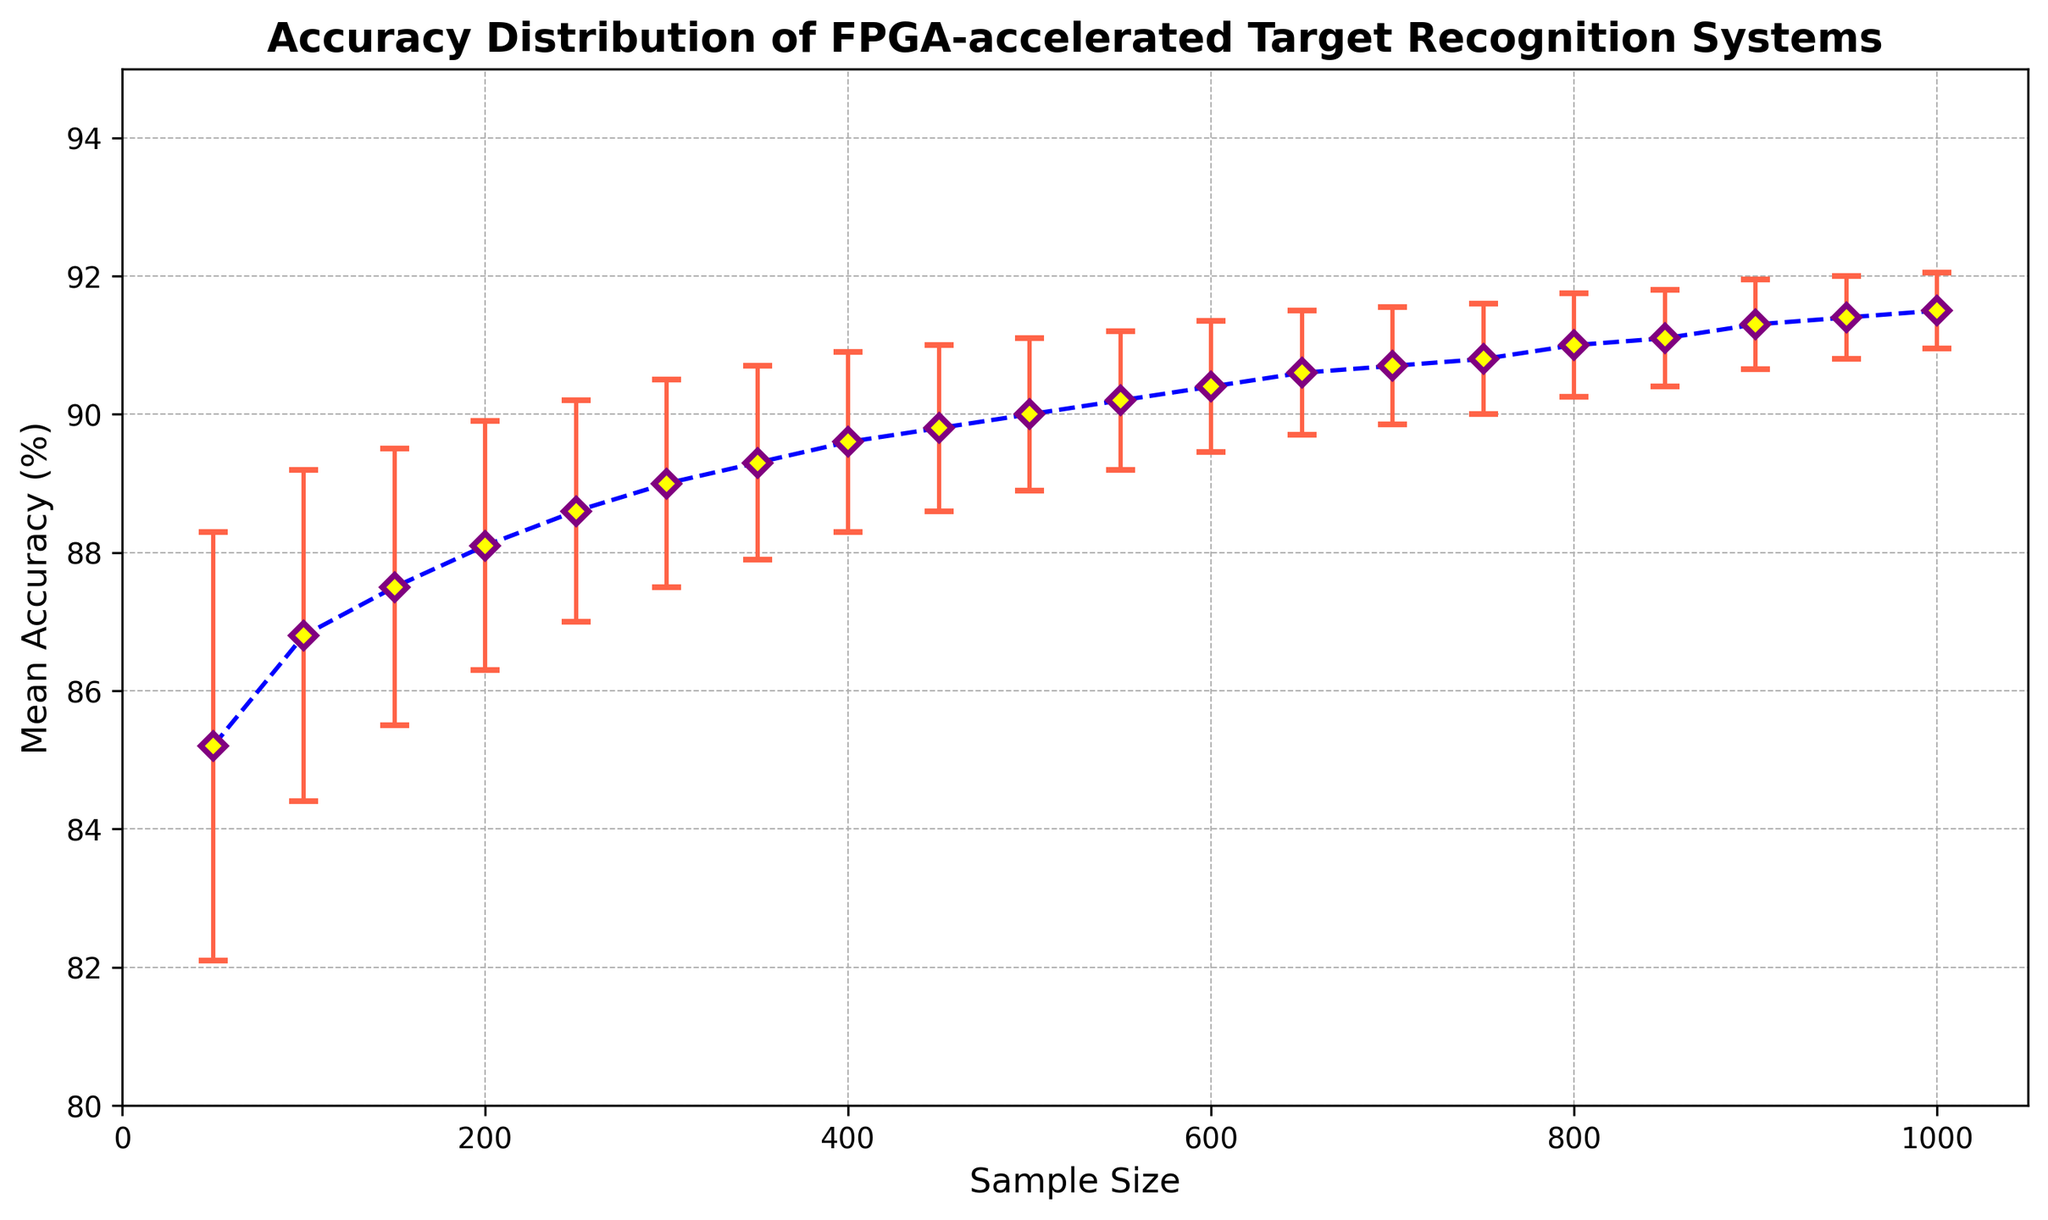How does the mean accuracy change as the sample size increases from 50 to 1000? Initially, at a sample size of 50, the mean accuracy is 85.2%. As the sample size increases, the mean accuracy steadily rises, reaching 91.5% at a sample size of 1000. Thus, there is a clear upward trend in mean accuracy as the sample size grows.
Answer: The mean accuracy increases from 85.2% to 91.5% What is the difference in mean accuracy between a sample size of 50 and a sample size of 1000? The mean accuracy at a sample size of 50 is 85.2%, and at 1000, it is 91.5%. The difference is calculated as 91.5% - 85.2%.
Answer: 6.3% For which sample size does the mean accuracy first reach or exceed 90%? By examining the plot, we see that the mean accuracy reaches 90% at a sample size of 500. This is the first instance where the mean accuracy reaches or exceeds 90%.
Answer: 500 How does the error margin behave as the sample size increases? The error margin decreases as the sample size increases. Starting from an error margin of 3.1 at a sample size of 50 down to 0.55 at a sample size of 1000, the trend is downward.
Answer: The error margin decreases At what sample size does the error margin fall below 1.0? Looking at the error margin values on the plot, we see that it falls below 1.0 at a sample size of 550.
Answer: 550 Are there any sample size intervals where the mean accuracy plateaus or changes minimally? Examining the plot, between the sample sizes of 700 and 800, the mean accuracy changes minimally from 90.7% to 91.0%, indicating a plateau in this interval.
Answer: 700 to 800 Which sample size interval shows the steepest increase in mean accuracy? The steepest increase occurs between sample sizes 50 and 100 where the mean accuracy jumps from 85.2% to 86.8%, indicating a 1.6% increase.
Answer: 50 to 100 What can be inferred from the shape and slope of the error bars in the plot? As the sample size increases, the length of the error bars decreases, indicating increased precision in the mean accuracy estimates with larger sample sizes.
Answer: Larger sample sizes lead to more precise estimates (smaller error bars) What is the visual significance of the color used for the error bars? The error bars are colored tomato red, which visually highlights the error margins conspicuously, emphasizing the variability in accuracy at different sample sizes.
Answer: Highlights variability What do the yellow markers with purple edges represent in the plot? The yellow markers with purple edges represent the mean accuracy at each sample size. These visually distinct markers help to clearly identify the data points on the plot.
Answer: Mean accuracy data points 